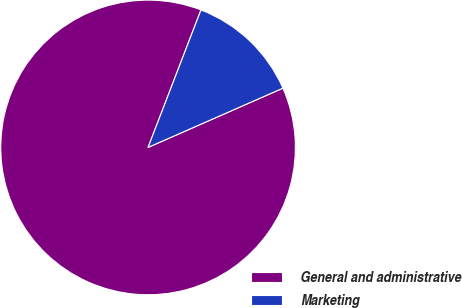<chart> <loc_0><loc_0><loc_500><loc_500><pie_chart><fcel>General and administrative<fcel>Marketing<nl><fcel>87.44%<fcel>12.56%<nl></chart> 